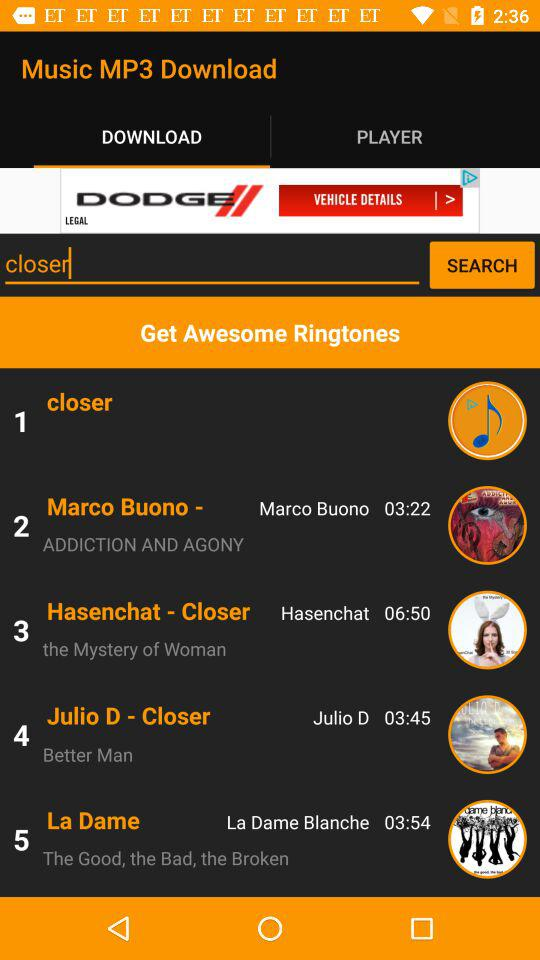What is the name of the song by La Dame Blanche? Th name of the song is "The Good, the Bad, the Broken". 